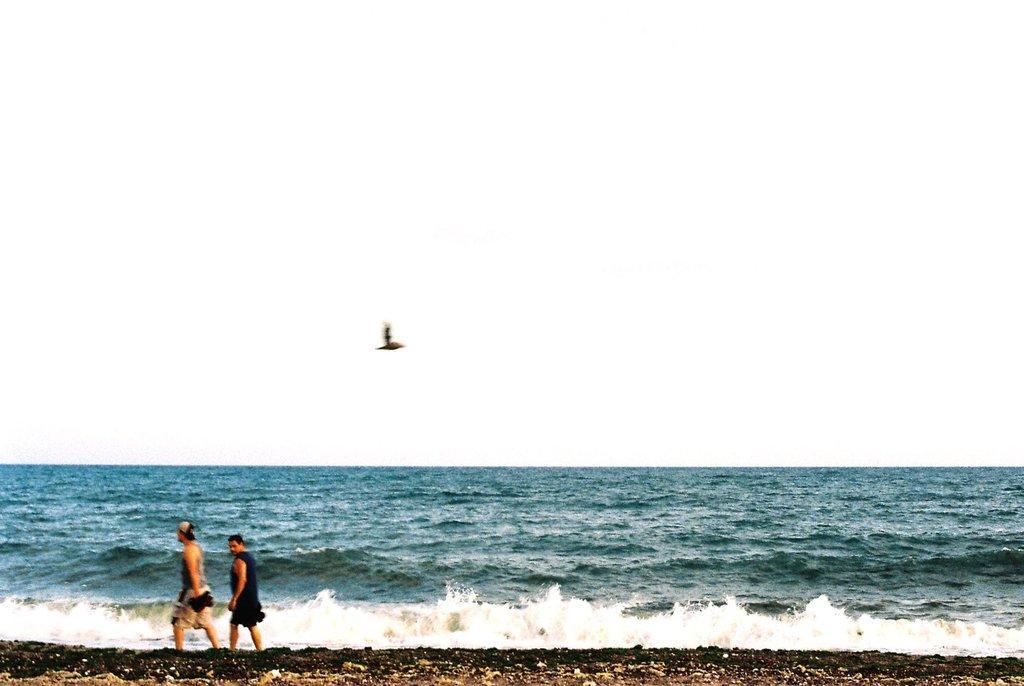Could you give a brief overview of what you see in this image? In this image at the bottom left hand side there are two people walking and in the middle there is a sea and the background is the sky. 